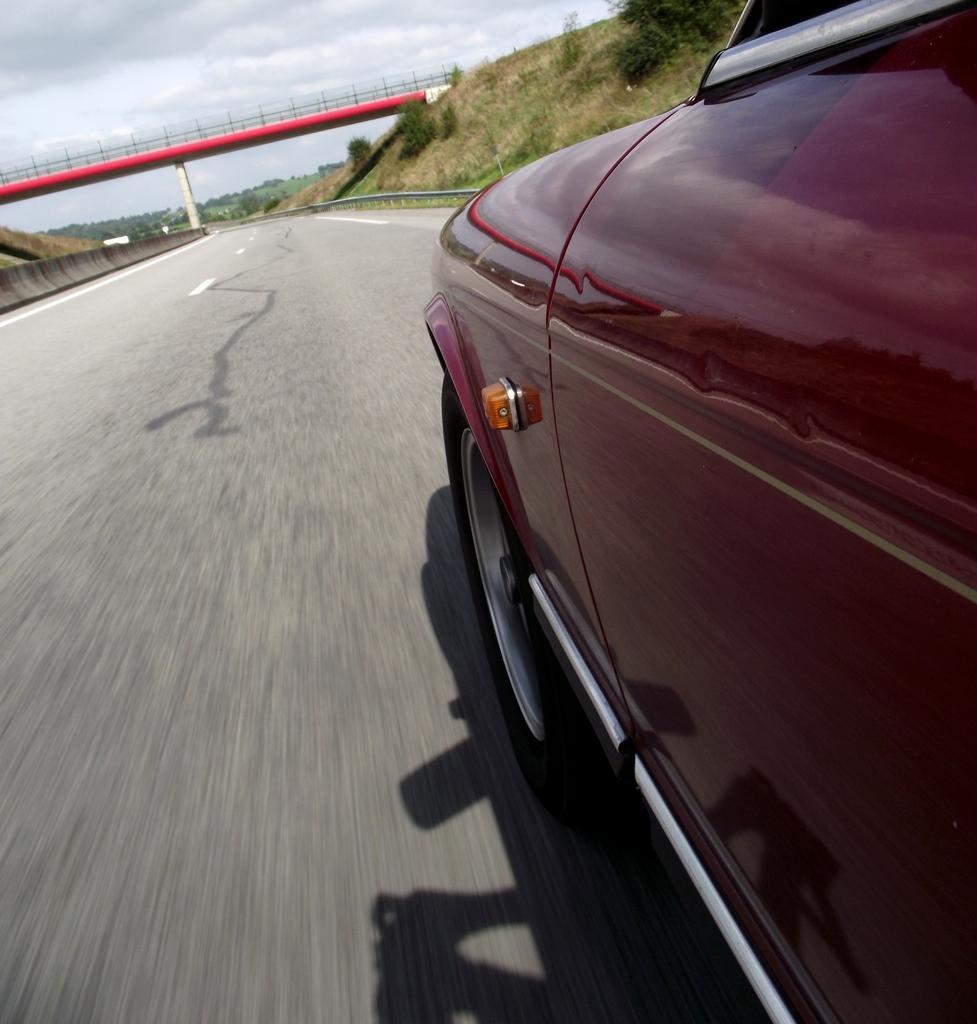In one or two sentences, can you explain what this image depicts? In this image we can see a car on the road, there is a bridged, there are plants, trees, also we can see the sky. 